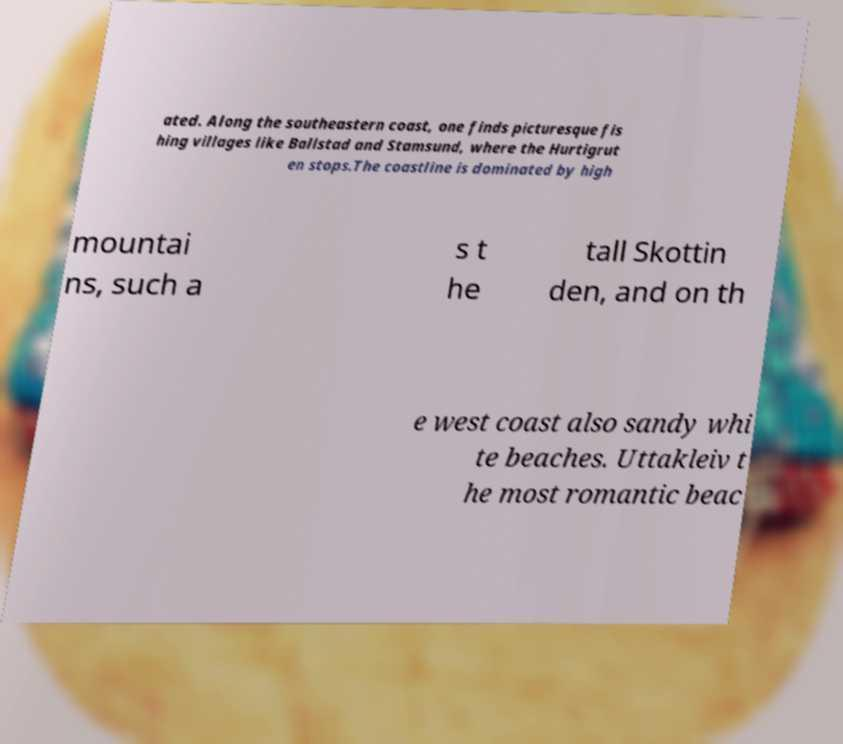Can you accurately transcribe the text from the provided image for me? ated. Along the southeastern coast, one finds picturesque fis hing villages like Ballstad and Stamsund, where the Hurtigrut en stops.The coastline is dominated by high mountai ns, such a s t he tall Skottin den, and on th e west coast also sandy whi te beaches. Uttakleiv t he most romantic beac 